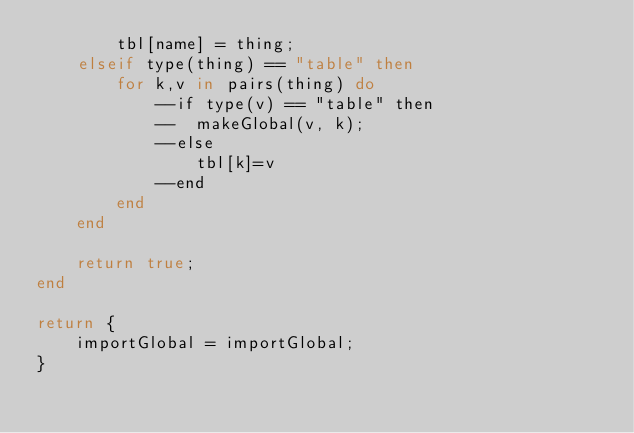<code> <loc_0><loc_0><loc_500><loc_500><_Lua_>		tbl[name] = thing;
	elseif type(thing) == "table" then
		for k,v in pairs(thing) do 
			--if type(v) == "table" then
			--	makeGlobal(v, k);
			--else
				tbl[k]=v
			--end 
		end
	end
	
	return true;
end

return {
	importGlobal = importGlobal;
}</code> 